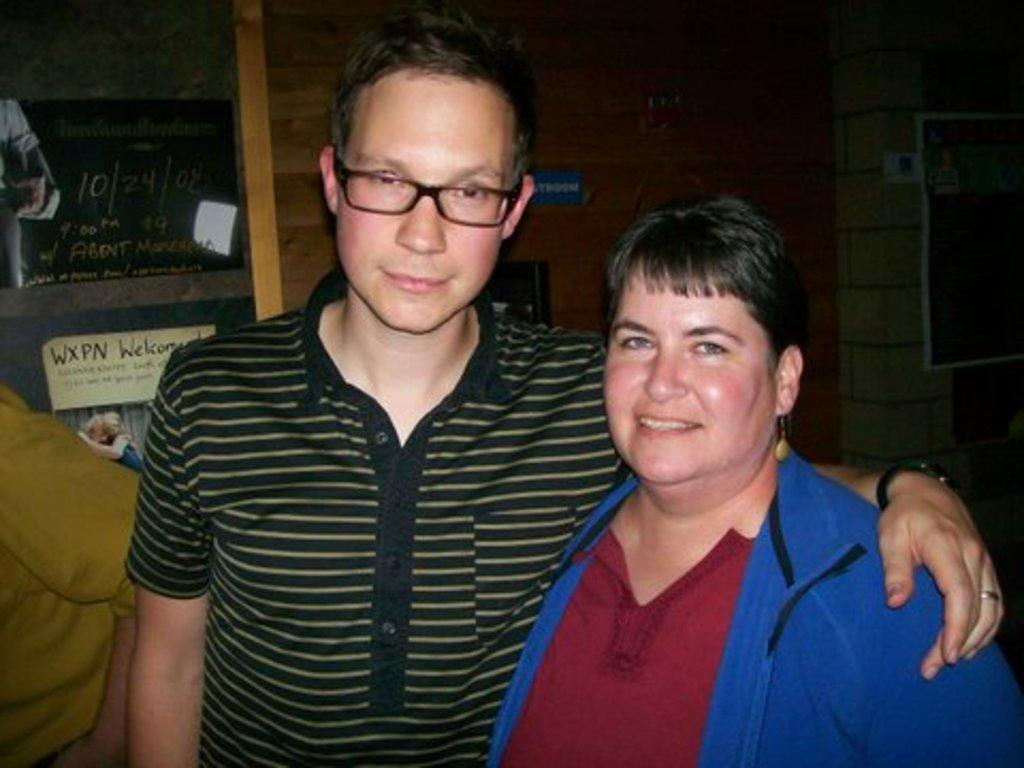Who are the people in the image? There is a man and a woman in the image. What is the woman doing in the image? The woman is smiling in the image. What can be seen in the background of the image? There is a wooden wall in the background of the image. Where is the toothbrush located in the image? There is no toothbrush present in the image. What type of throne can be seen in the image? There is no throne present in the image. 